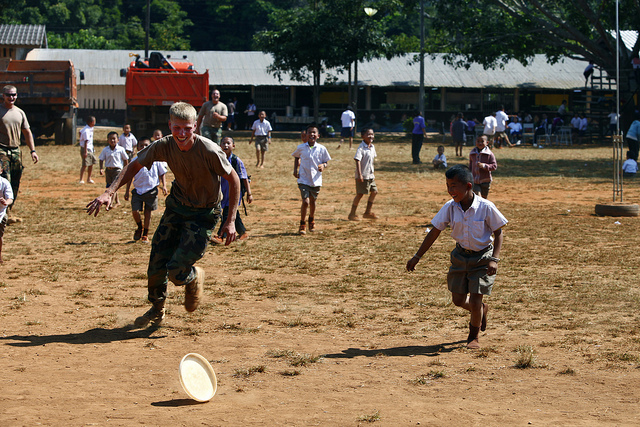<image>Which man has bad knees? It is ambiguous which man has bad knees. Which man has bad knees? It is ambiguous which man has bad knees. It is difficult to determine based on the given information. 